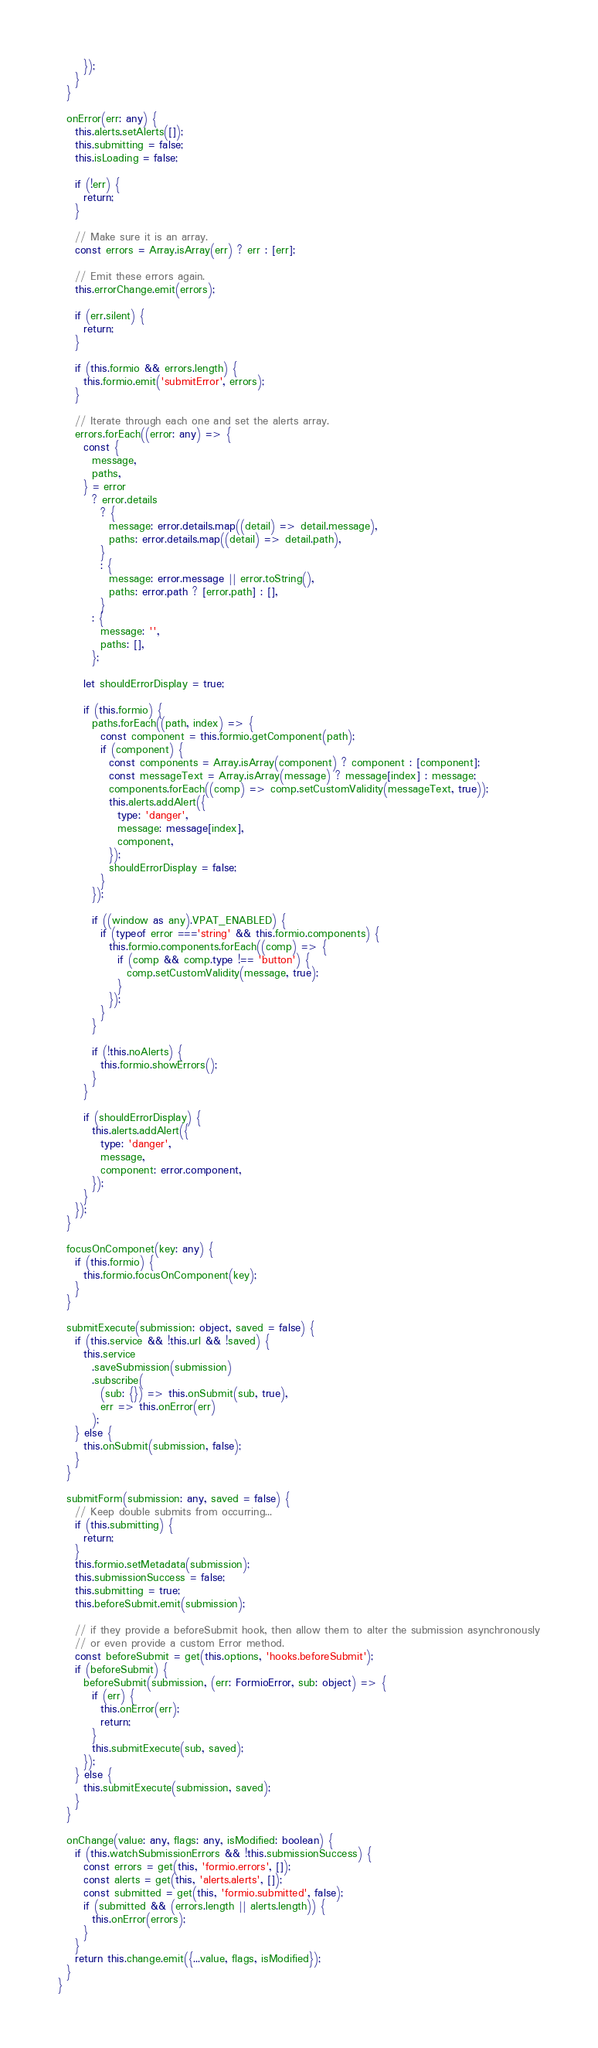Convert code to text. <code><loc_0><loc_0><loc_500><loc_500><_TypeScript_>      });
    }
  }

  onError(err: any) {
    this.alerts.setAlerts([]);
    this.submitting = false;
    this.isLoading = false;

    if (!err) {
      return;
    }

    // Make sure it is an array.
    const errors = Array.isArray(err) ? err : [err];

    // Emit these errors again.
    this.errorChange.emit(errors);

    if (err.silent) {
      return;
    }

    if (this.formio && errors.length) {
      this.formio.emit('submitError', errors);
    }

    // Iterate through each one and set the alerts array.
    errors.forEach((error: any) => {
      const {
        message,
        paths,
      } = error
        ? error.details
          ? {
            message: error.details.map((detail) => detail.message),
            paths: error.details.map((detail) => detail.path),
          }
          : {
            message: error.message || error.toString(),
            paths: error.path ? [error.path] : [],
          }
        : {
          message: '',
          paths: [],
        };

      let shouldErrorDisplay = true;

      if (this.formio) {
        paths.forEach((path, index) => {
          const component = this.formio.getComponent(path);
          if (component) {
            const components = Array.isArray(component) ? component : [component];
            const messageText = Array.isArray(message) ? message[index] : message;
            components.forEach((comp) => comp.setCustomValidity(messageText, true));
            this.alerts.addAlert({
              type: 'danger',
              message: message[index],
              component,
            });
            shouldErrorDisplay = false;
          }
        });

        if ((window as any).VPAT_ENABLED) {
          if (typeof error ==='string' && this.formio.components) {
            this.formio.components.forEach((comp) => {
              if (comp && comp.type !== 'button') {
                comp.setCustomValidity(message, true);
              }
            });
          }
        }

        if (!this.noAlerts) {
          this.formio.showErrors();
        }
      }

      if (shouldErrorDisplay) {
        this.alerts.addAlert({
          type: 'danger',
          message,
          component: error.component,
        });
      }
    });
  }

  focusOnComponet(key: any) {
    if (this.formio) {
      this.formio.focusOnComponent(key);
    }
  }

  submitExecute(submission: object, saved = false) {
    if (this.service && !this.url && !saved) {
      this.service
        .saveSubmission(submission)
        .subscribe(
          (sub: {}) => this.onSubmit(sub, true),
          err => this.onError(err)
        );
    } else {
      this.onSubmit(submission, false);
    }
  }

  submitForm(submission: any, saved = false) {
    // Keep double submits from occurring...
    if (this.submitting) {
      return;
    }
    this.formio.setMetadata(submission);
    this.submissionSuccess = false;
    this.submitting = true;
    this.beforeSubmit.emit(submission);

    // if they provide a beforeSubmit hook, then allow them to alter the submission asynchronously
    // or even provide a custom Error method.
    const beforeSubmit = get(this.options, 'hooks.beforeSubmit');
    if (beforeSubmit) {
      beforeSubmit(submission, (err: FormioError, sub: object) => {
        if (err) {
          this.onError(err);
          return;
        }
        this.submitExecute(sub, saved);
      });
    } else {
      this.submitExecute(submission, saved);
    }
  }

  onChange(value: any, flags: any, isModified: boolean) {
    if (this.watchSubmissionErrors && !this.submissionSuccess) {
      const errors = get(this, 'formio.errors', []);
      const alerts = get(this, 'alerts.alerts', []);
      const submitted = get(this, 'formio.submitted', false);
      if (submitted && (errors.length || alerts.length)) {
        this.onError(errors);
      }
    }
    return this.change.emit({...value, flags, isModified});
  }
}
</code> 